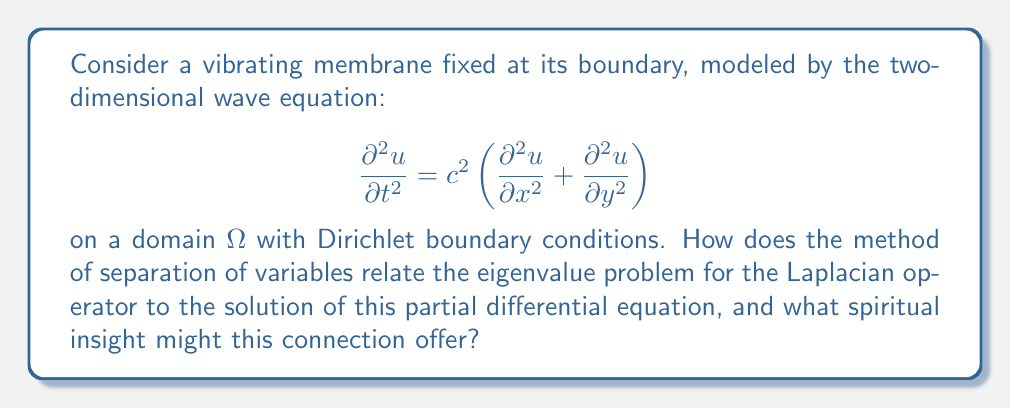Help me with this question. 1. First, we apply the method of separation of variables, assuming a solution of the form:
   $$u(x,y,t) = X(x)Y(y)T(t)$$

2. Substituting this into the wave equation and dividing by $XYT$, we get:
   $$\frac{T''}{c^2T} = \frac{X''}{X} + \frac{Y''}{Y} = -\lambda$$
   where $\lambda$ is a separation constant.

3. This leads to two equations:
   a) Time-dependent equation: $T'' + c^2\lambda T = 0$
   b) Spatial equation: $\nabla^2\phi + \lambda\phi = 0$, where $\phi(x,y) = X(x)Y(y)$

4. The spatial equation is an eigenvalue problem for the Laplacian operator $\nabla^2$. Its solutions $\phi_n$ are eigenfunctions with corresponding eigenvalues $\lambda_n$.

5. The general solution to the wave equation can be expressed as a superposition of these eigenfunctions:
   $$u(x,y,t) = \sum_{n=1}^{\infty} (A_n \cos(\omega_n t) + B_n \sin(\omega_n t))\phi_n(x,y)$$
   where $\omega_n = c\sqrt{\lambda_n}$

6. Spiritual insight: This connection between the spectral theory of the Laplacian and the solution of the wave equation can be seen as a reflection of the harmony between the eternal (eigenvalues and eigenfunctions) and the temporal (time-dependent solutions). It illustrates how complex phenomena in our physical world can be understood through fundamental, unchanging principles, much like how the diversity of Islamic jurisprudence is built upon the unchanging foundations of the Quran and Sunnah.
Answer: The eigenvalue problem for the Laplacian determines the spatial modes $\phi_n(x,y)$ and frequencies $\omega_n = c\sqrt{\lambda_n}$ of the membrane's vibration. 